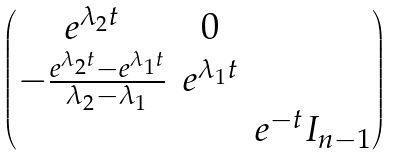Convert formula to latex. <formula><loc_0><loc_0><loc_500><loc_500>\begin{pmatrix} \begin{matrix} e ^ { \lambda _ { 2 } t } & 0 \\ - \frac { e ^ { \lambda _ { 2 } t } - e ^ { \lambda _ { 1 } t } } { \lambda _ { 2 } - \lambda _ { 1 } } & e ^ { \lambda _ { 1 } t } \end{matrix} & \\ & e ^ { - t } I _ { n - 1 } \end{pmatrix}</formula> 